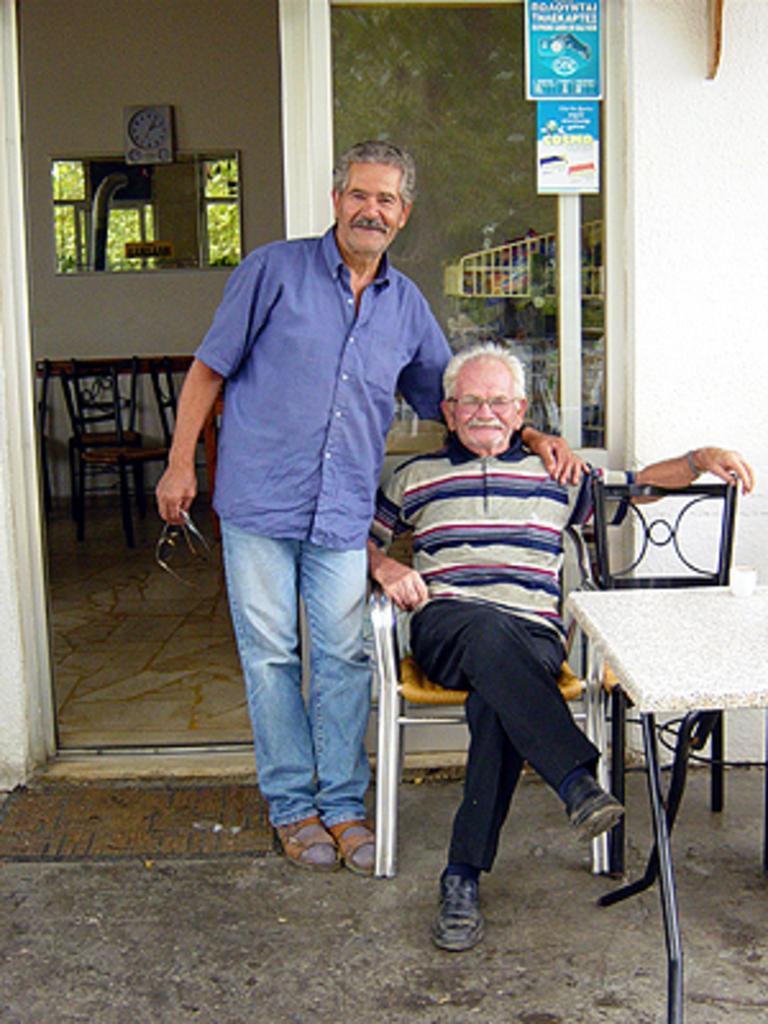How would you summarize this image in a sentence or two? this picture shows two men a man seated on the chair and other man standing and we see few chairs and table 